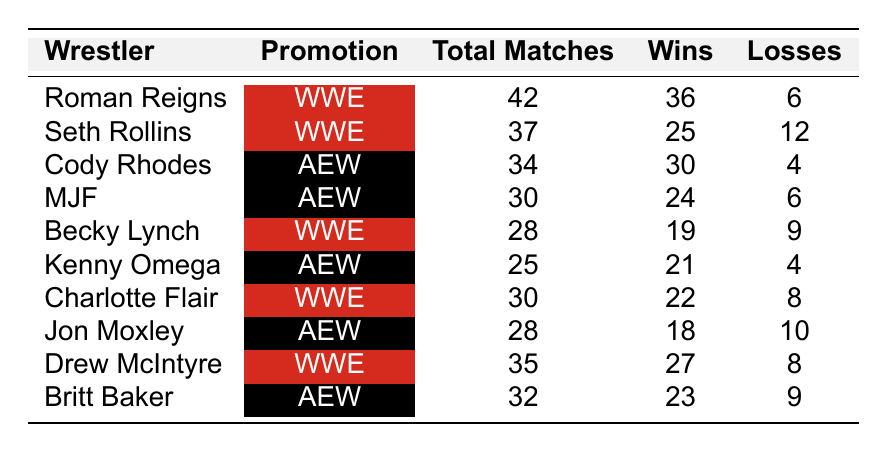What is the total number of wins for Roman Reigns? The table shows that Roman Reigns has a win record of 36.
Answer: 36 Who among these wrestlers has the least number of losses? By comparing the losses of each wrestler in the table, Cody Rhodes and Kenny Omega both have 4 losses, which is the lowest.
Answer: 4 How many total matches did Charlotte Flair compete in? The table indicates that Charlotte Flair competed in 30 matches.
Answer: 30 What is the win-loss ratio for Drew McIntyre? Drew McIntyre's record shows 27 wins and 8 losses. The win-loss ratio is calculated as 27 (wins) / 8 (losses) = 3.375.
Answer: 3.375 Did Becky Lynch win more matches than she lost? Becky Lynch has 19 wins and 9 losses, which shows she won more than lost.
Answer: Yes What is the average number of total matches for wrestlers in WWE? The WWE wrestlers' total matches are: 42 (Reigns) + 37 (Rollins) + 28 (Lynch) + 30 (Flair) + 35 (McIntyre) = 172. There are 5 WWE wrestlers, so the average is 172/5 = 34.4.
Answer: 34.4 Which wrestler has the highest number of total matches? Roman Reigns has the highest total matches with 42, compared to others in the list.
Answer: Roman Reigns How many more wins does Cody Rhodes have compared to MJF? Cody Rhodes has 30 wins and MJF has 24 wins. The difference is 30 - 24 = 6.
Answer: 6 Which promotion had more wrestlers in the table? Counting the wrestlers, WWE has 5 (Reigns, Rollins, Lynch, Flair, McIntyre) and AEW has 5 (Rhodes, MJF, Omega, Moxley, Baker). Both promotions are equal in number.
Answer: Equal What is the total number of wins for all wrestlers in AEW? The total wins for AEW wrestlers are 30 (Rhodes) + 24 (MJF) + 21 (Omega) + 18 (Moxley) + 23 (Baker) = 116.
Answer: 116 